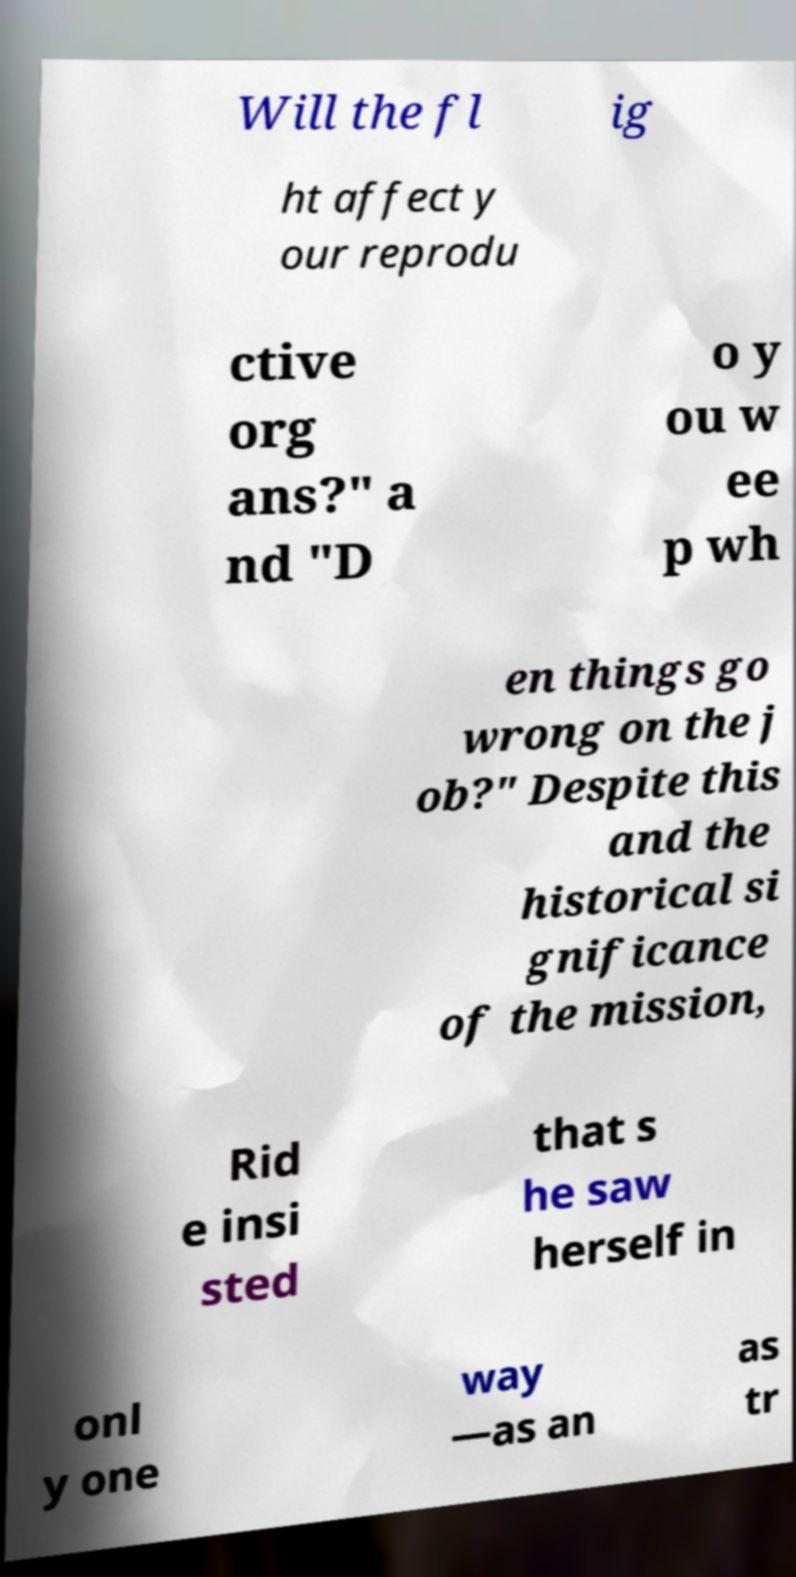Please identify and transcribe the text found in this image. Will the fl ig ht affect y our reprodu ctive org ans?" a nd "D o y ou w ee p wh en things go wrong on the j ob?" Despite this and the historical si gnificance of the mission, Rid e insi sted that s he saw herself in onl y one way —as an as tr 